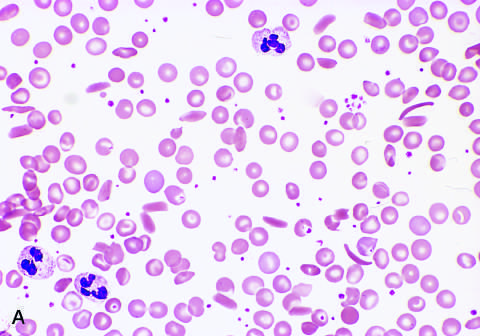does low magnification show sickle cells, anisocytosis, poikilocytosis, and target cells?
Answer the question using a single word or phrase. Yes 